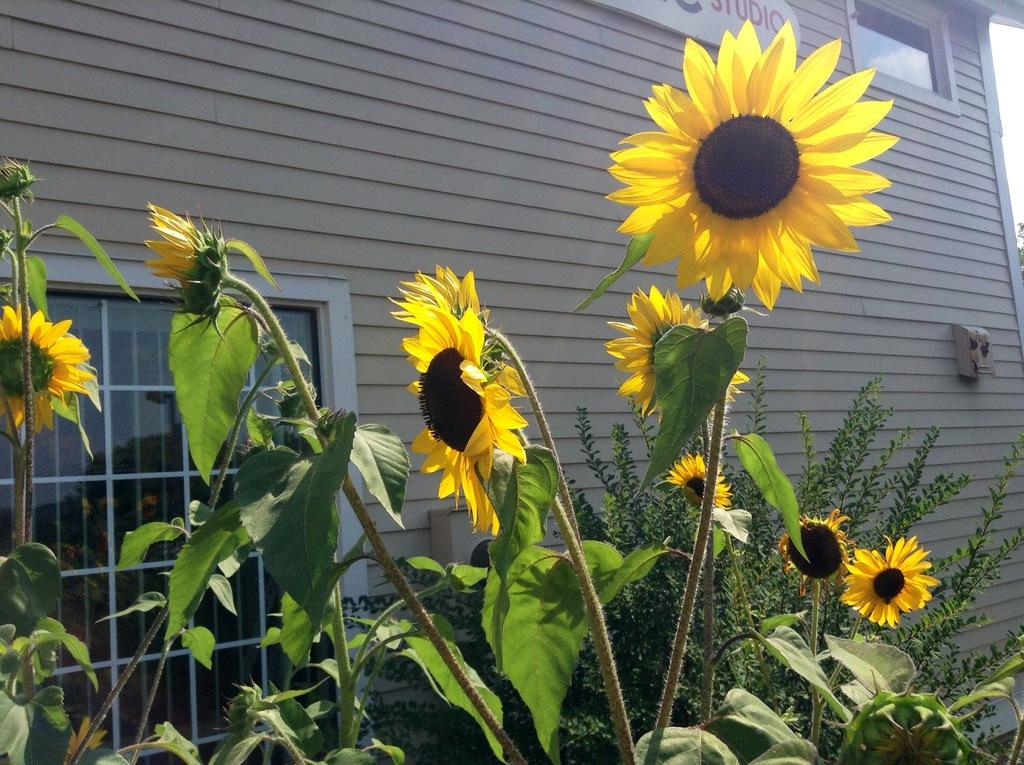What type of living organisms can be seen in the image? Plants and flowers are visible in the image. What architectural feature is present in the image? There is a window in the image. What type of air circulation system is visible in the image? There is ventilation in the image. What structure is present with text in the image? There is a building with text in the image. How many celery stalks can be seen in the image? There is no celery present in the image. What type of visitor is shown in the image? There is no visitor depicted in the image. 